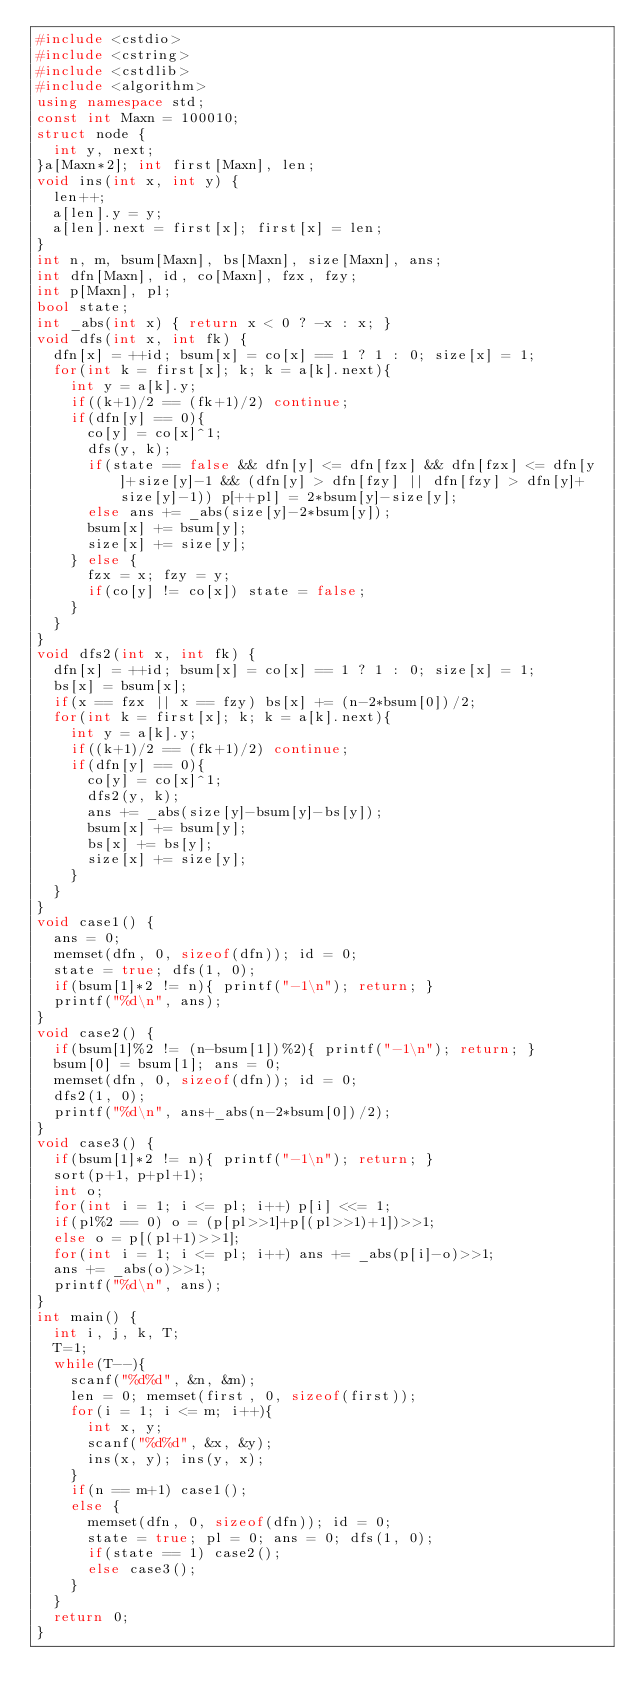Convert code to text. <code><loc_0><loc_0><loc_500><loc_500><_C++_>#include <cstdio>
#include <cstring>
#include <cstdlib>
#include <algorithm>
using namespace std;
const int Maxn = 100010;
struct node {
	int y, next;
}a[Maxn*2]; int first[Maxn], len;
void ins(int x, int y) {
	len++;
	a[len].y = y;
	a[len].next = first[x]; first[x] = len;
}
int n, m, bsum[Maxn], bs[Maxn], size[Maxn], ans;
int dfn[Maxn], id, co[Maxn], fzx, fzy;
int p[Maxn], pl;
bool state;
int _abs(int x) { return x < 0 ? -x : x; }
void dfs(int x, int fk) {
	dfn[x] = ++id; bsum[x] = co[x] == 1 ? 1 : 0; size[x] = 1;
	for(int k = first[x]; k; k = a[k].next){
		int y = a[k].y;
		if((k+1)/2 == (fk+1)/2) continue;
		if(dfn[y] == 0){
			co[y] = co[x]^1;
			dfs(y, k);
			if(state == false && dfn[y] <= dfn[fzx] && dfn[fzx] <= dfn[y]+size[y]-1 && (dfn[y] > dfn[fzy] || dfn[fzy] > dfn[y]+size[y]-1)) p[++pl] = 2*bsum[y]-size[y];
			else ans += _abs(size[y]-2*bsum[y]);
			bsum[x] += bsum[y];
			size[x] += size[y];
		} else {
			fzx = x; fzy = y;
			if(co[y] != co[x]) state = false;
		}
	}
}
void dfs2(int x, int fk) {
	dfn[x] = ++id; bsum[x] = co[x] == 1 ? 1 : 0; size[x] = 1;
	bs[x] = bsum[x];
	if(x == fzx || x == fzy) bs[x] += (n-2*bsum[0])/2;
	for(int k = first[x]; k; k = a[k].next){
		int y = a[k].y;
		if((k+1)/2 == (fk+1)/2) continue;
		if(dfn[y] == 0){
			co[y] = co[x]^1;
			dfs2(y, k);
			ans += _abs(size[y]-bsum[y]-bs[y]);
			bsum[x] += bsum[y];
			bs[x] += bs[y];
			size[x] += size[y];
		}
	}
}
void case1() {
	ans = 0;
	memset(dfn, 0, sizeof(dfn)); id = 0;
	state = true; dfs(1, 0);
	if(bsum[1]*2 != n){ printf("-1\n"); return; }
	printf("%d\n", ans);
}
void case2() {
	if(bsum[1]%2 != (n-bsum[1])%2){ printf("-1\n"); return; }
	bsum[0] = bsum[1]; ans = 0;
	memset(dfn, 0, sizeof(dfn)); id = 0;
	dfs2(1, 0);
	printf("%d\n", ans+_abs(n-2*bsum[0])/2);
}
void case3() {
	if(bsum[1]*2 != n){ printf("-1\n"); return; }
	sort(p+1, p+pl+1);
	int o;
	for(int i = 1; i <= pl; i++) p[i] <<= 1;
	if(pl%2 == 0) o = (p[pl>>1]+p[(pl>>1)+1])>>1;
	else o = p[(pl+1)>>1];
	for(int i = 1; i <= pl; i++) ans += _abs(p[i]-o)>>1;
	ans += _abs(o)>>1;
	printf("%d\n", ans);
}
int main() {
	int i, j, k, T;
	T=1;
	while(T--){
		scanf("%d%d", &n, &m);
		len = 0; memset(first, 0, sizeof(first));
		for(i = 1; i <= m; i++){
			int x, y;
			scanf("%d%d", &x, &y);
			ins(x, y); ins(y, x);
		}
		if(n == m+1) case1();
		else {
			memset(dfn, 0, sizeof(dfn)); id = 0;
			state = true; pl = 0; ans = 0; dfs(1, 0);
			if(state == 1) case2();
			else case3();
		}
	}
	return 0;
}
</code> 